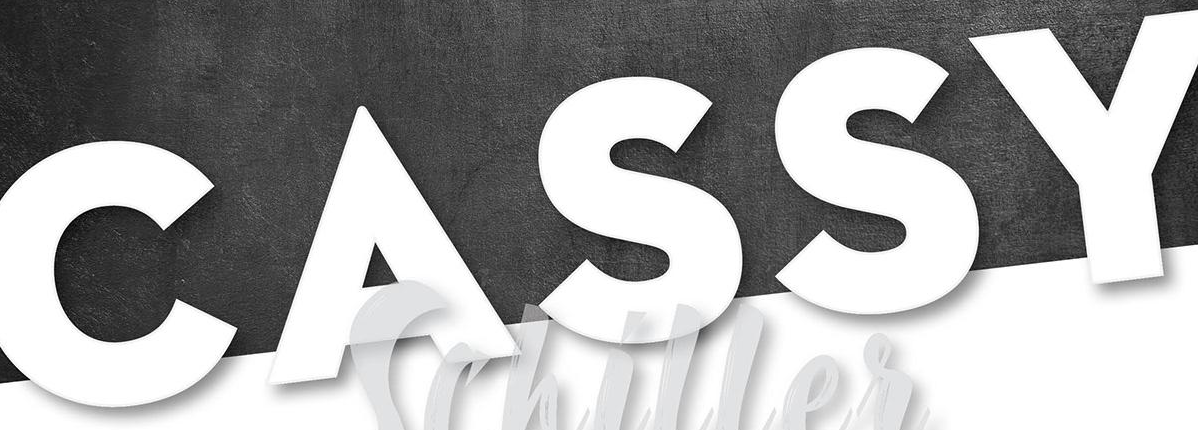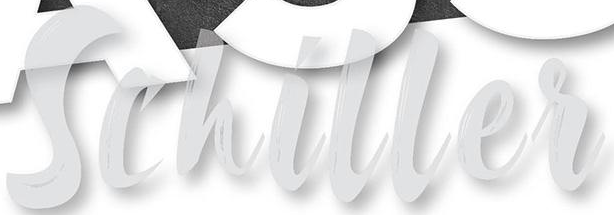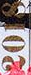Transcribe the words shown in these images in order, separated by a semicolon. CASSY; Schiller; 2018 